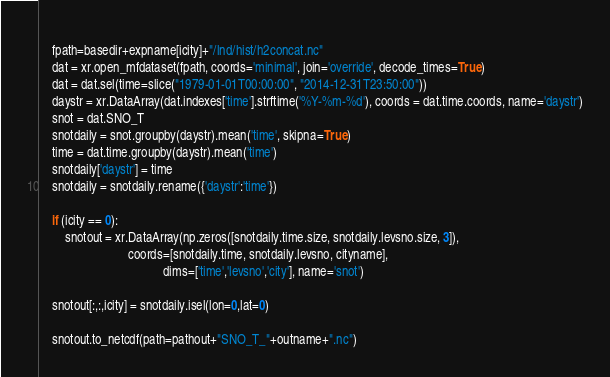Convert code to text. <code><loc_0><loc_0><loc_500><loc_500><_Python_>    
    fpath=basedir+expname[icity]+"/lnd/hist/h2concat.nc"
    dat = xr.open_mfdataset(fpath, coords='minimal', join='override', decode_times=True)
    dat = dat.sel(time=slice("1979-01-01T00:00:00", "2014-12-31T23:50:00"))
    daystr = xr.DataArray(dat.indexes['time'].strftime('%Y-%m-%d'), coords = dat.time.coords, name='daystr')
    snot = dat.SNO_T
    snotdaily = snot.groupby(daystr).mean('time', skipna=True)
    time = dat.time.groupby(daystr).mean('time')
    snotdaily['daystr'] = time
    snotdaily = snotdaily.rename({'daystr':'time'})

    if (icity == 0): 
        snotout = xr.DataArray(np.zeros([snotdaily.time.size, snotdaily.levsno.size, 3]), 
                            coords=[snotdaily.time, snotdaily.levsno, cityname],
                                       dims=['time','levsno','city'], name='snot')
    
    snotout[:,:,icity] = snotdaily.isel(lon=0,lat=0)
    
    snotout.to_netcdf(path=pathout+"SNO_T_"+outname+".nc")
</code> 